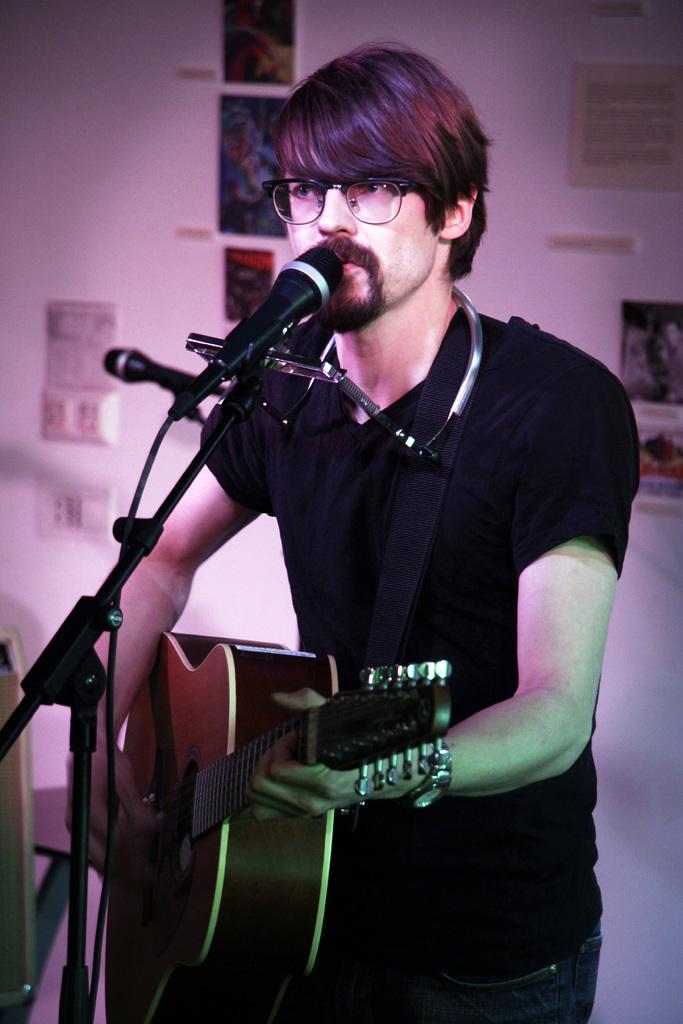What is the man in the image wearing? The man is wearing a black shirt. What is the man doing in the image? The man is playing a guitar and standing in front of a microphone. What can be seen on the wall in the background of the image? There are photo frames on a wall in the background. Can you identify any electrical components in the image? Yes, there is a socket visible in the image. How many boys are playing with the daughter in the image? There is no mention of boys or a daughter in the image; it features a man playing a guitar and standing in front of a microphone. 